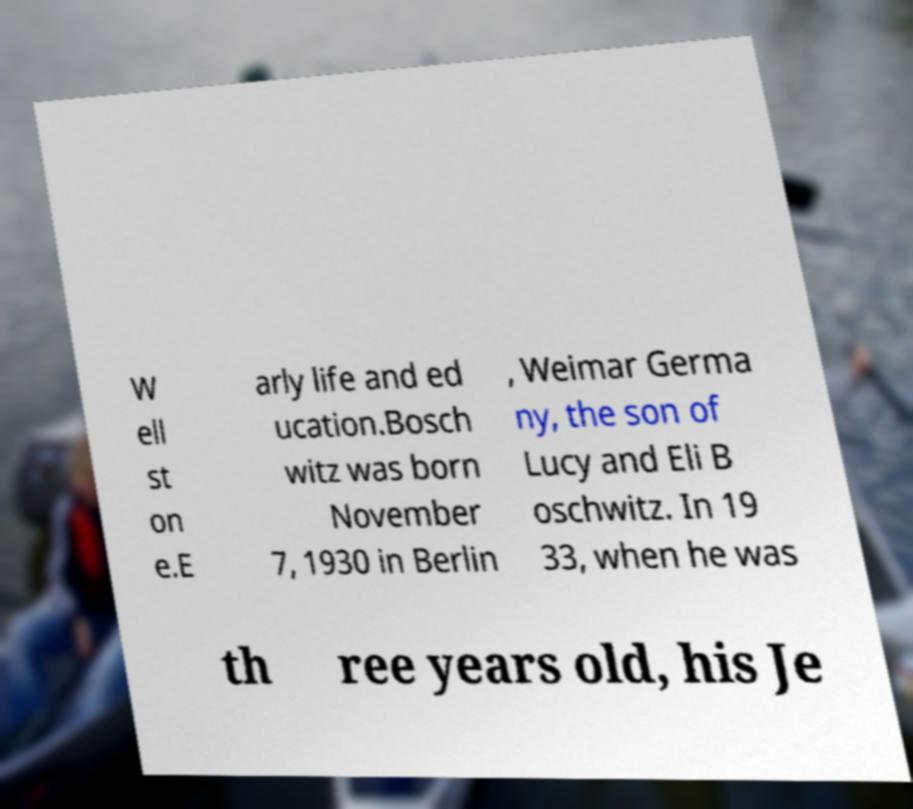What messages or text are displayed in this image? I need them in a readable, typed format. W ell st on e.E arly life and ed ucation.Bosch witz was born November 7, 1930 in Berlin , Weimar Germa ny, the son of Lucy and Eli B oschwitz. In 19 33, when he was th ree years old, his Je 